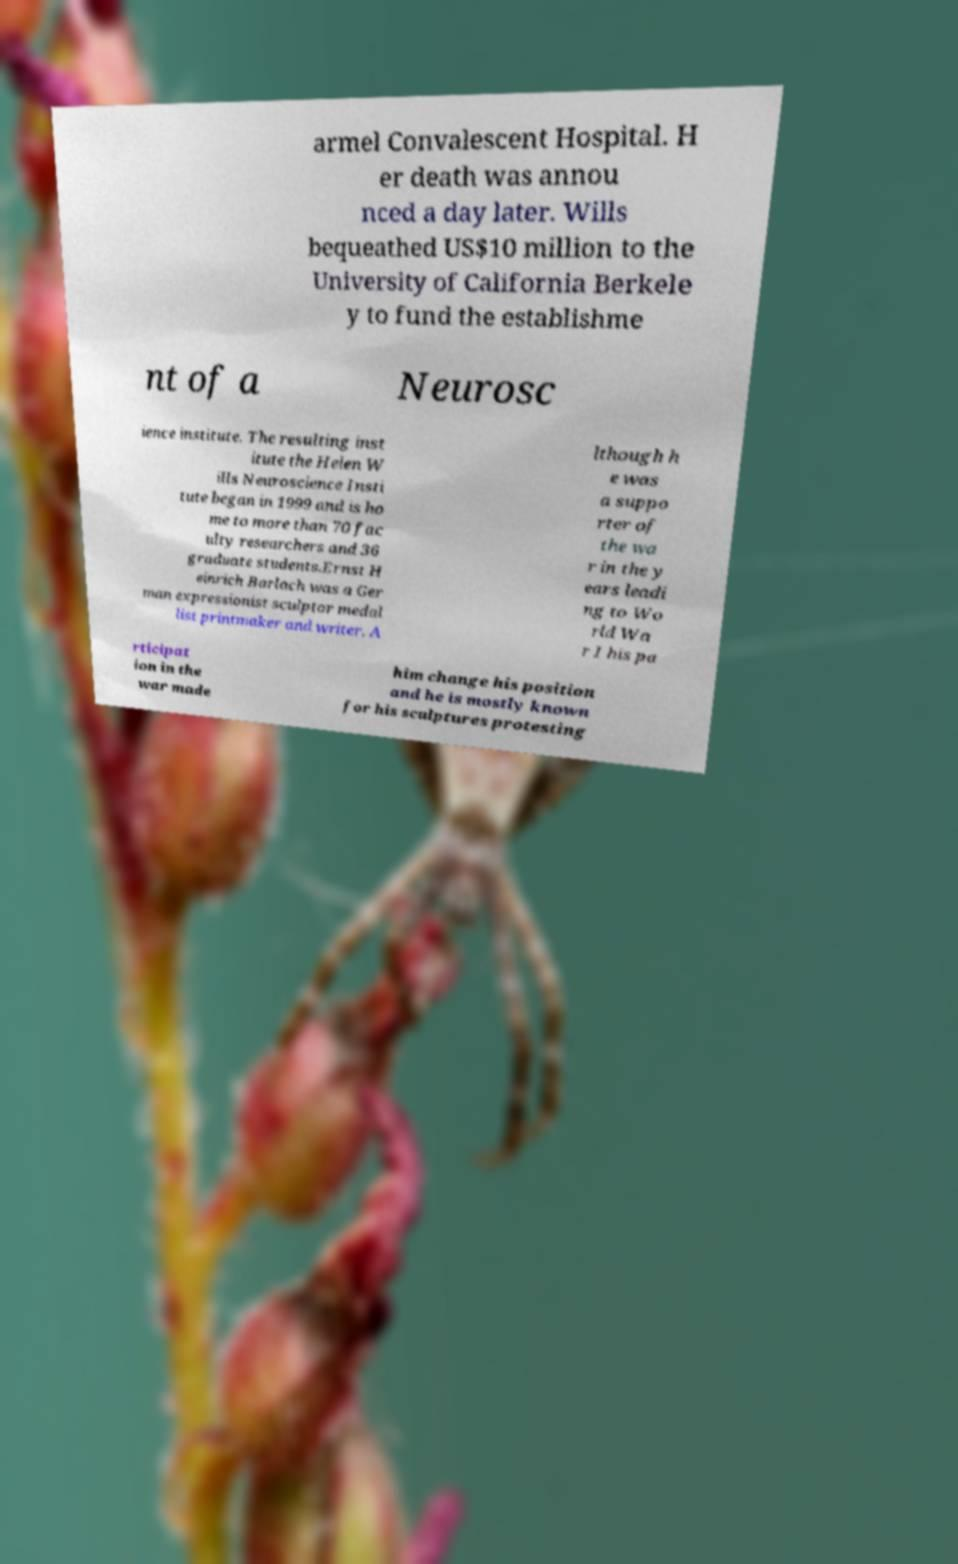Can you read and provide the text displayed in the image?This photo seems to have some interesting text. Can you extract and type it out for me? armel Convalescent Hospital. H er death was annou nced a day later. Wills bequeathed US$10 million to the University of California Berkele y to fund the establishme nt of a Neurosc ience institute. The resulting inst itute the Helen W ills Neuroscience Insti tute began in 1999 and is ho me to more than 70 fac ulty researchers and 36 graduate students.Ernst H einrich Barlach was a Ger man expressionist sculptor medal list printmaker and writer. A lthough h e was a suppo rter of the wa r in the y ears leadi ng to Wo rld Wa r I his pa rticipat ion in the war made him change his position and he is mostly known for his sculptures protesting 